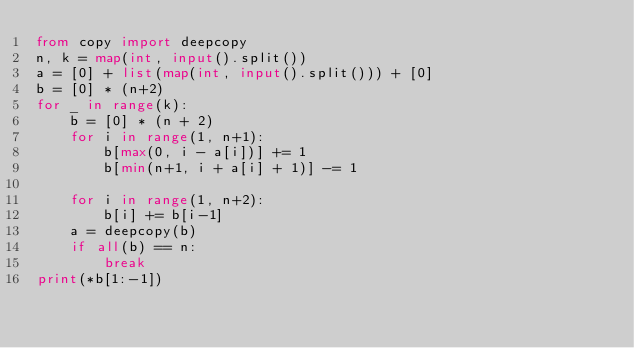<code> <loc_0><loc_0><loc_500><loc_500><_Python_>from copy import deepcopy
n, k = map(int, input().split())
a = [0] + list(map(int, input().split())) + [0]
b = [0] * (n+2)
for _ in range(k):
    b = [0] * (n + 2)
    for i in range(1, n+1):
        b[max(0, i - a[i])] += 1
        b[min(n+1, i + a[i] + 1)] -= 1

    for i in range(1, n+2):
        b[i] += b[i-1]
    a = deepcopy(b)
    if all(b) == n:
        break
print(*b[1:-1])

</code> 